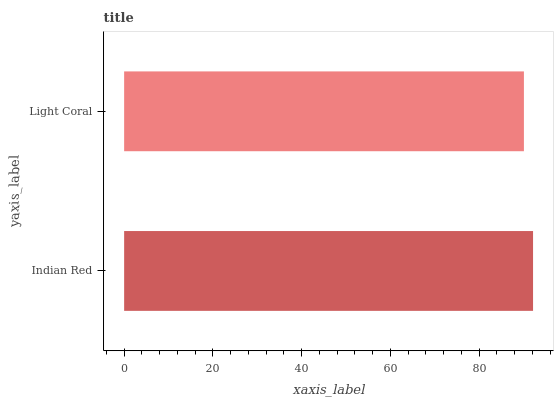Is Light Coral the minimum?
Answer yes or no. Yes. Is Indian Red the maximum?
Answer yes or no. Yes. Is Light Coral the maximum?
Answer yes or no. No. Is Indian Red greater than Light Coral?
Answer yes or no. Yes. Is Light Coral less than Indian Red?
Answer yes or no. Yes. Is Light Coral greater than Indian Red?
Answer yes or no. No. Is Indian Red less than Light Coral?
Answer yes or no. No. Is Indian Red the high median?
Answer yes or no. Yes. Is Light Coral the low median?
Answer yes or no. Yes. Is Light Coral the high median?
Answer yes or no. No. Is Indian Red the low median?
Answer yes or no. No. 